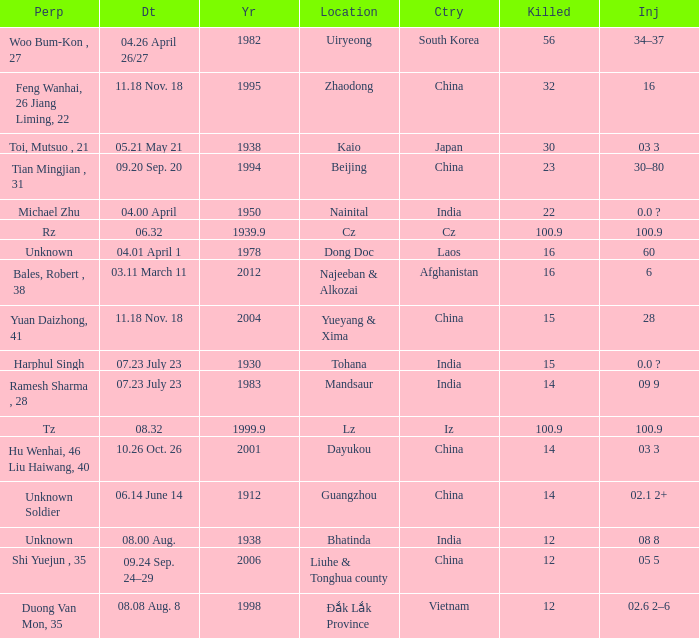What is the nation, when "killed" is 10 Iz. Parse the full table. {'header': ['Perp', 'Dt', 'Yr', 'Location', 'Ctry', 'Killed', 'Inj'], 'rows': [['Woo Bum-Kon , 27', '04.26 April 26/27', '1982', 'Uiryeong', 'South Korea', '56', '34–37'], ['Feng Wanhai, 26 Jiang Liming, 22', '11.18 Nov. 18', '1995', 'Zhaodong', 'China', '32', '16'], ['Toi, Mutsuo , 21', '05.21 May 21', '1938', 'Kaio', 'Japan', '30', '03 3'], ['Tian Mingjian , 31', '09.20 Sep. 20', '1994', 'Beijing', 'China', '23', '30–80'], ['Michael Zhu', '04.00 April', '1950', 'Nainital', 'India', '22', '0.0 ?'], ['Rz', '06.32', '1939.9', 'Cz', 'Cz', '100.9', '100.9'], ['Unknown', '04.01 April 1', '1978', 'Dong Doc', 'Laos', '16', '60'], ['Bales, Robert , 38', '03.11 March 11', '2012', 'Najeeban & Alkozai', 'Afghanistan', '16', '6'], ['Yuan Daizhong, 41', '11.18 Nov. 18', '2004', 'Yueyang & Xima', 'China', '15', '28'], ['Harphul Singh', '07.23 July 23', '1930', 'Tohana', 'India', '15', '0.0 ?'], ['Ramesh Sharma , 28', '07.23 July 23', '1983', 'Mandsaur', 'India', '14', '09 9'], ['Tz', '08.32', '1999.9', 'Lz', 'Iz', '100.9', '100.9'], ['Hu Wenhai, 46 Liu Haiwang, 40', '10.26 Oct. 26', '2001', 'Dayukou', 'China', '14', '03 3'], ['Unknown Soldier', '06.14 June 14', '1912', 'Guangzhou', 'China', '14', '02.1 2+'], ['Unknown', '08.00 Aug.', '1938', 'Bhatinda', 'India', '12', '08 8'], ['Shi Yuejun , 35', '09.24 Sep. 24–29', '2006', 'Liuhe & Tonghua county', 'China', '12', '05 5'], ['Duong Van Mon, 35', '08.08 Aug. 8', '1998', 'Đắk Lắk Province', 'Vietnam', '12', '02.6 2–6']]} 